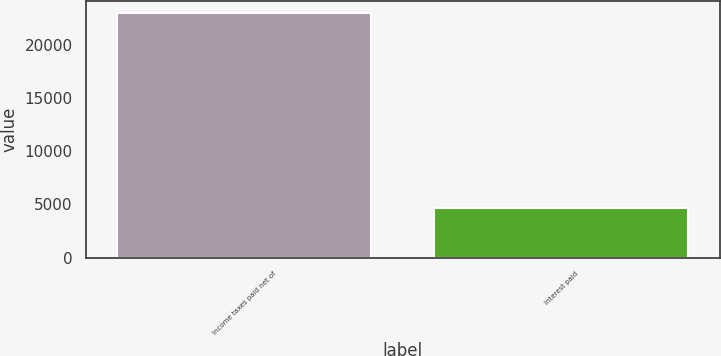<chart> <loc_0><loc_0><loc_500><loc_500><bar_chart><fcel>Income taxes paid net of<fcel>Interest paid<nl><fcel>22966<fcel>4637<nl></chart> 